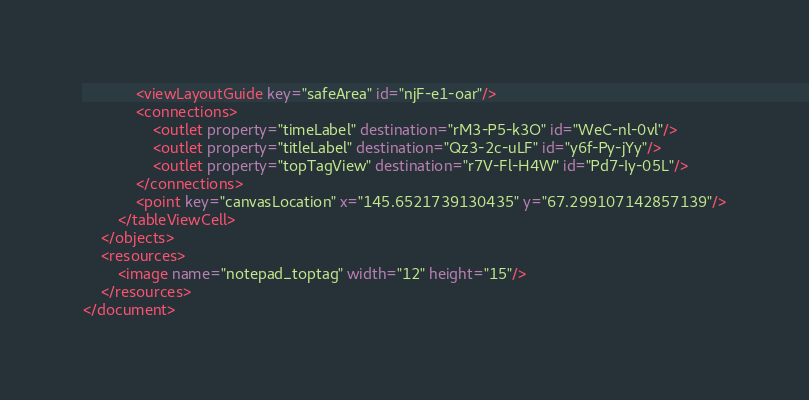Convert code to text. <code><loc_0><loc_0><loc_500><loc_500><_XML_>            <viewLayoutGuide key="safeArea" id="njF-e1-oar"/>
            <connections>
                <outlet property="timeLabel" destination="rM3-P5-k3O" id="WeC-nl-0vl"/>
                <outlet property="titleLabel" destination="Qz3-2c-uLF" id="y6f-Py-jYy"/>
                <outlet property="topTagView" destination="r7V-Fl-H4W" id="Pd7-Iy-05L"/>
            </connections>
            <point key="canvasLocation" x="145.6521739130435" y="67.299107142857139"/>
        </tableViewCell>
    </objects>
    <resources>
        <image name="notepad_toptag" width="12" height="15"/>
    </resources>
</document>
</code> 